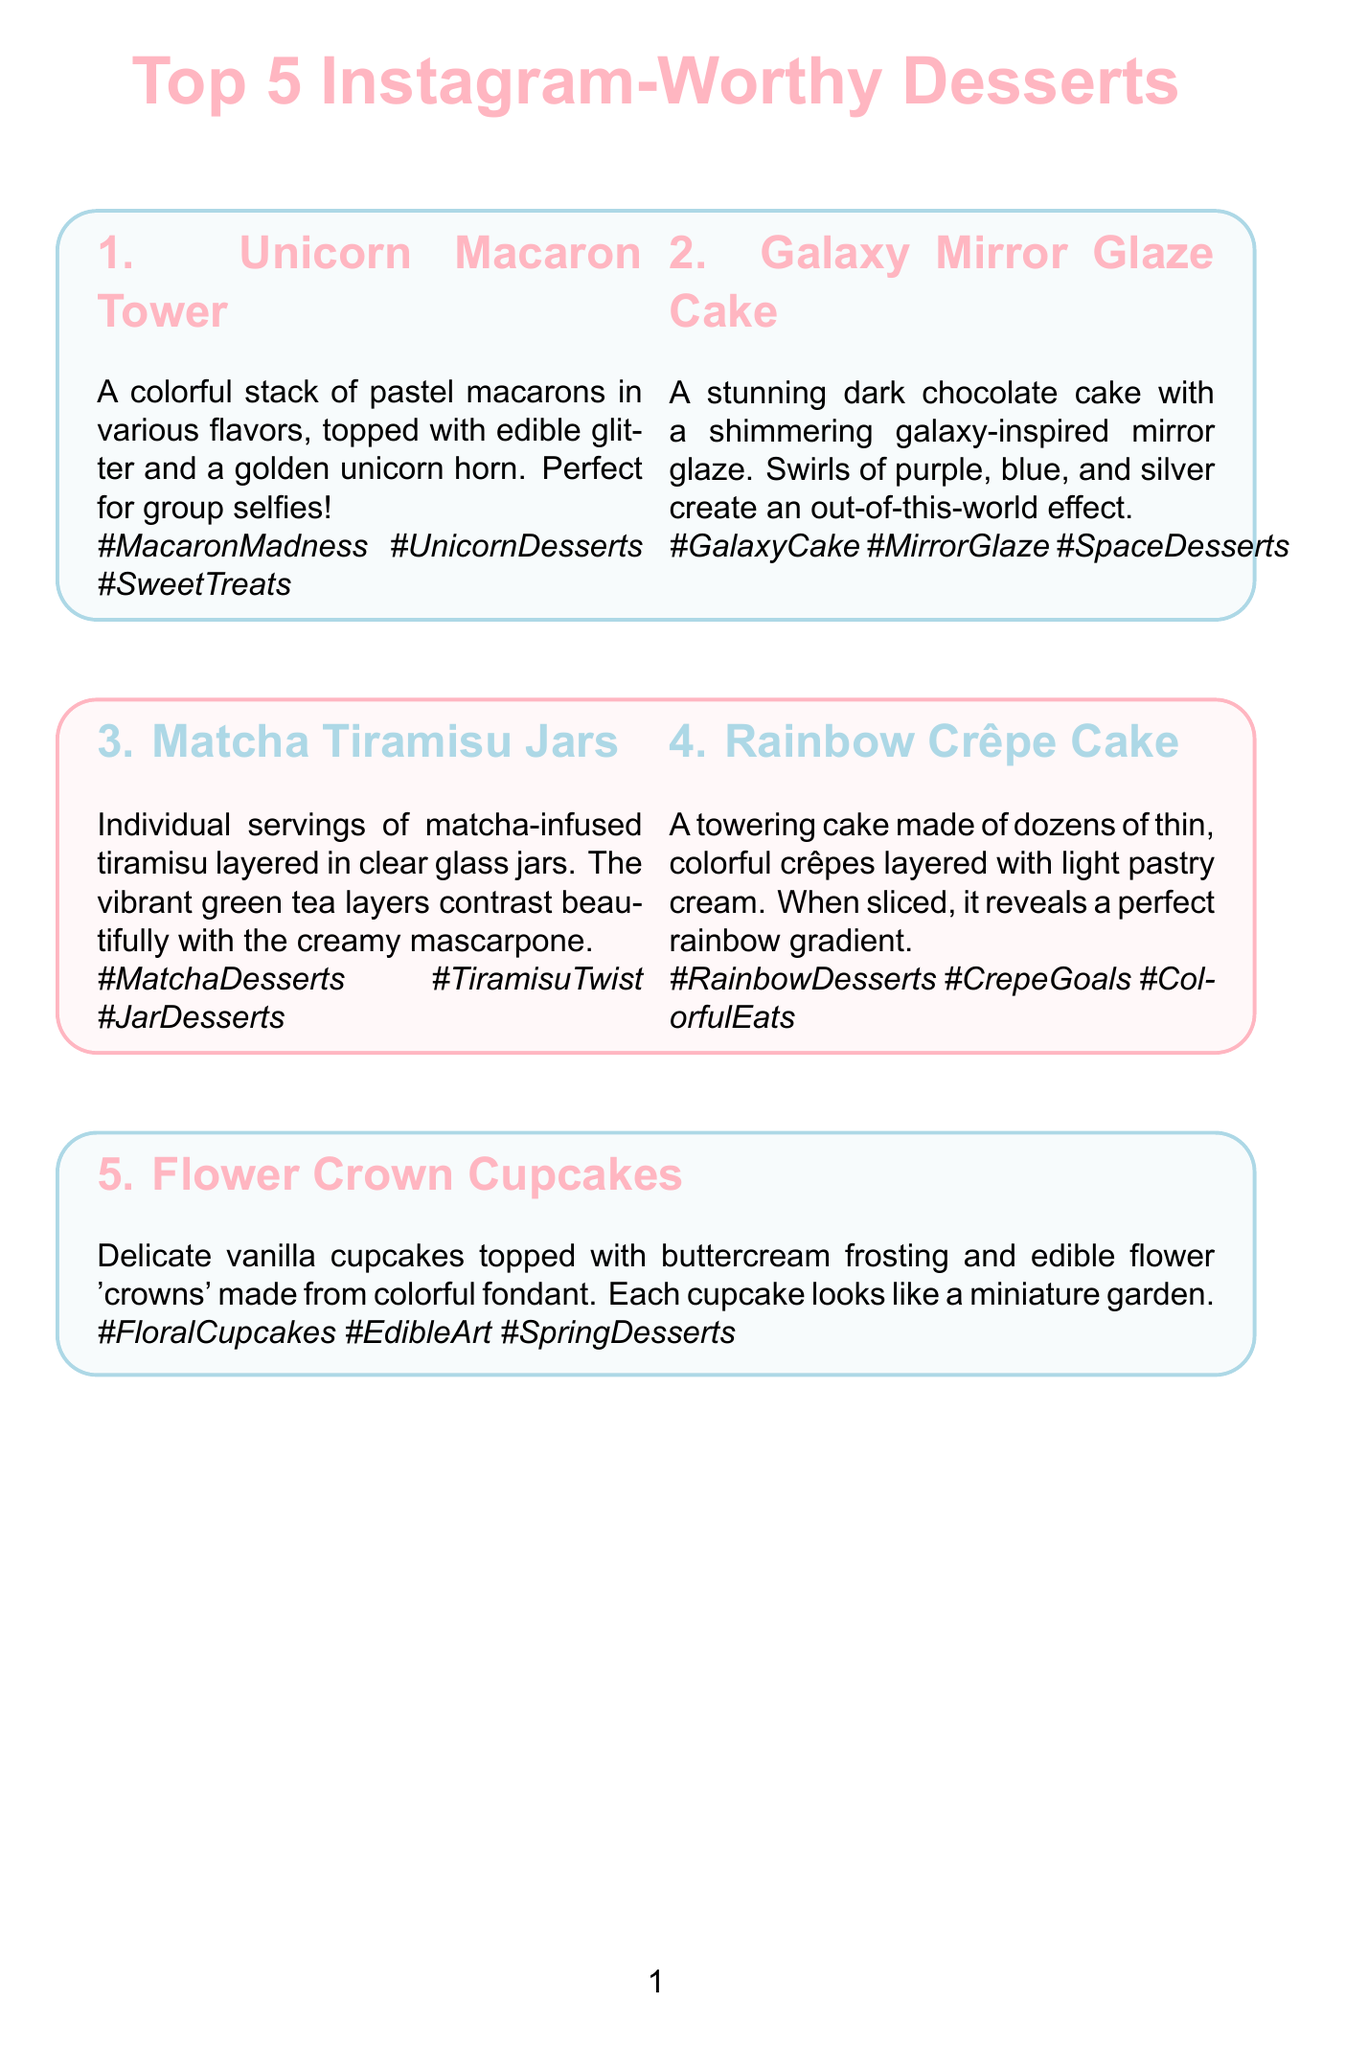What is the name of the first dessert? The name of the first dessert is mentioned in the section for "1. Unicorn Macaron Tower."
Answer: Unicorn Macaron Tower How many desserts are featured in the newsletter? The document specifically lists five desserts in the Top 5 Instagram-Worthy Desserts.
Answer: 5 What is the main ingredient in the Galaxy Mirror Glaze Cake? The description highlights that the cake is dark chocolate, making it the primary ingredient.
Answer: Dark chocolate What color are the layers in the Matcha Tiramisu Jars? The layers are described as vibrant green tea layers, which is their distinct color.
Answer: Green Which dessert is ideal for group selfies? The description for the first dessert states that it is "Perfect for group selfies!"
Answer: Unicorn Macaron Tower What is recommended for making dessert photos pop? The social media tips mention a specific suggestion related to lighting for photos.
Answer: Natural lighting What type of video content is suggested for TikTok? The document contains an idea for a specific type of video to create on TikTok using one engaging aspect of the dessert.
Answer: Quick transition video What is the hashtag associated with Flower Crown Cupcakes? The hashtags listed for this dessert include elements that represent its theme.
Answer: #FloralCupcakes Who is suggested for collaboration on social media? The document refers to a specific influencer who could be reached out to for collaboration.
Answer: @CampusFoodie 